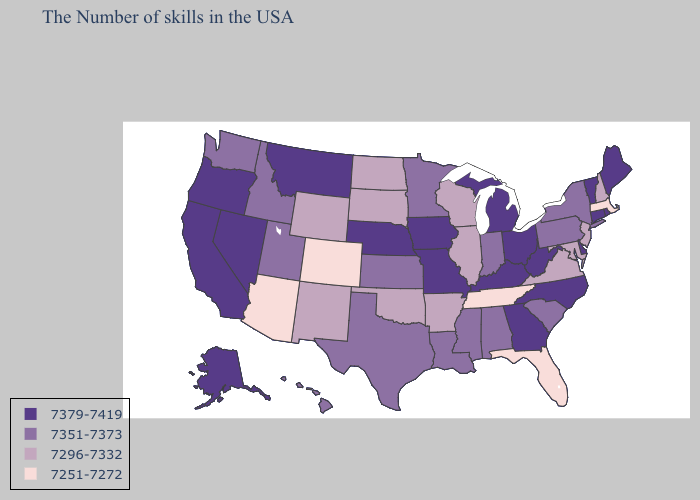Among the states that border New Mexico , does Colorado have the highest value?
Concise answer only. No. Name the states that have a value in the range 7351-7373?
Concise answer only. New York, Pennsylvania, South Carolina, Indiana, Alabama, Mississippi, Louisiana, Minnesota, Kansas, Texas, Utah, Idaho, Washington, Hawaii. Among the states that border Oregon , does California have the highest value?
Keep it brief. Yes. Which states hav the highest value in the South?
Keep it brief. Delaware, North Carolina, West Virginia, Georgia, Kentucky. What is the lowest value in the USA?
Give a very brief answer. 7251-7272. Name the states that have a value in the range 7296-7332?
Quick response, please. New Hampshire, New Jersey, Maryland, Virginia, Wisconsin, Illinois, Arkansas, Oklahoma, South Dakota, North Dakota, Wyoming, New Mexico. Name the states that have a value in the range 7296-7332?
Concise answer only. New Hampshire, New Jersey, Maryland, Virginia, Wisconsin, Illinois, Arkansas, Oklahoma, South Dakota, North Dakota, Wyoming, New Mexico. What is the value of Montana?
Short answer required. 7379-7419. Does Oregon have a lower value than South Carolina?
Short answer required. No. Does Mississippi have a higher value than Michigan?
Answer briefly. No. Which states have the lowest value in the Northeast?
Be succinct. Massachusetts. Which states have the highest value in the USA?
Short answer required. Maine, Rhode Island, Vermont, Connecticut, Delaware, North Carolina, West Virginia, Ohio, Georgia, Michigan, Kentucky, Missouri, Iowa, Nebraska, Montana, Nevada, California, Oregon, Alaska. Is the legend a continuous bar?
Keep it brief. No. What is the value of Maine?
Quick response, please. 7379-7419. What is the value of Indiana?
Quick response, please. 7351-7373. 